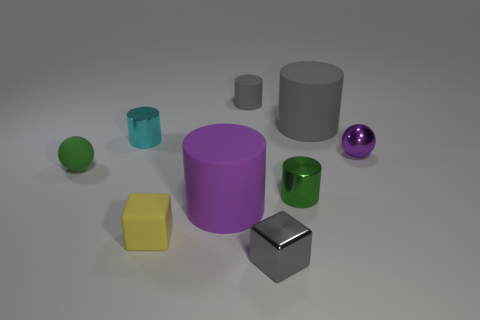If I wanted to stack an object on top of another, which objects would make a stable base? For stacking, stable bases would be provided by objects with flat horizontal surfaces. Therefore, the purple cylinder, the large grey cylinder, the yellow cube, and even the steel cube could serve as solid foundations for stacking another object on top. 